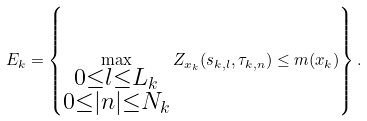<formula> <loc_0><loc_0><loc_500><loc_500>E _ { k } = \left \{ \max _ { \substack { 0 \leq l \leq L _ { k } \\ 0 \leq | n | \leq N _ { k } } } Z _ { x _ { k } } ( s _ { k , l } , \tau _ { k , n } ) \leq m ( x _ { k } ) \right \} .</formula> 